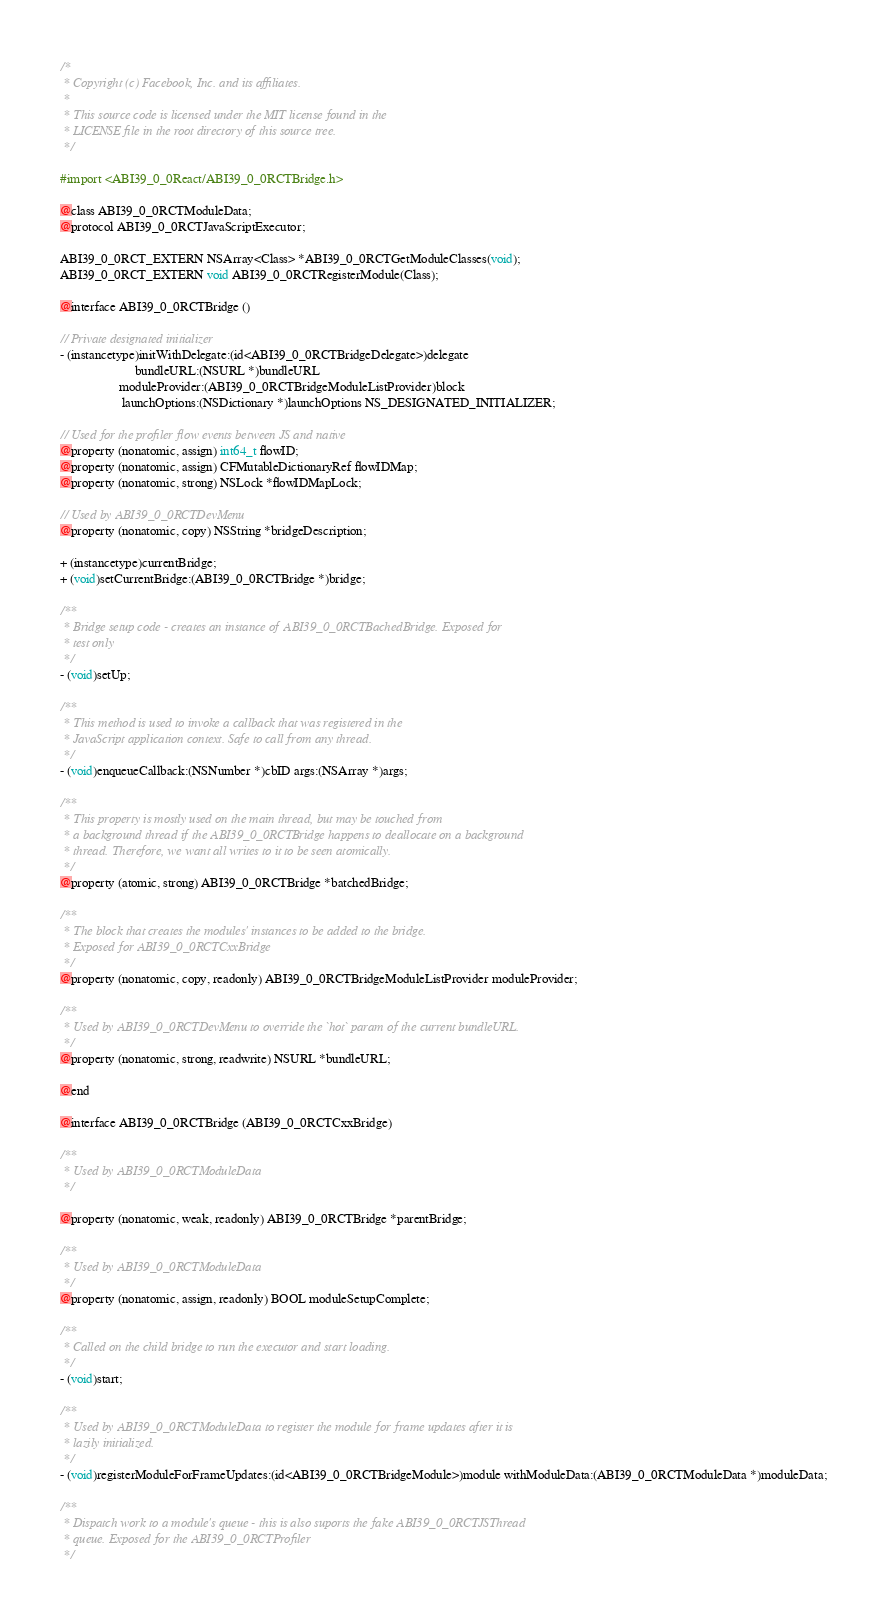Convert code to text. <code><loc_0><loc_0><loc_500><loc_500><_C_>/*
 * Copyright (c) Facebook, Inc. and its affiliates.
 *
 * This source code is licensed under the MIT license found in the
 * LICENSE file in the root directory of this source tree.
 */

#import <ABI39_0_0React/ABI39_0_0RCTBridge.h>

@class ABI39_0_0RCTModuleData;
@protocol ABI39_0_0RCTJavaScriptExecutor;

ABI39_0_0RCT_EXTERN NSArray<Class> *ABI39_0_0RCTGetModuleClasses(void);
ABI39_0_0RCT_EXTERN void ABI39_0_0RCTRegisterModule(Class);

@interface ABI39_0_0RCTBridge ()

// Private designated initializer
- (instancetype)initWithDelegate:(id<ABI39_0_0RCTBridgeDelegate>)delegate
                       bundleURL:(NSURL *)bundleURL
                  moduleProvider:(ABI39_0_0RCTBridgeModuleListProvider)block
                   launchOptions:(NSDictionary *)launchOptions NS_DESIGNATED_INITIALIZER;

// Used for the profiler flow events between JS and native
@property (nonatomic, assign) int64_t flowID;
@property (nonatomic, assign) CFMutableDictionaryRef flowIDMap;
@property (nonatomic, strong) NSLock *flowIDMapLock;

// Used by ABI39_0_0RCTDevMenu
@property (nonatomic, copy) NSString *bridgeDescription;

+ (instancetype)currentBridge;
+ (void)setCurrentBridge:(ABI39_0_0RCTBridge *)bridge;

/**
 * Bridge setup code - creates an instance of ABI39_0_0RCTBachedBridge. Exposed for
 * test only
 */
- (void)setUp;

/**
 * This method is used to invoke a callback that was registered in the
 * JavaScript application context. Safe to call from any thread.
 */
- (void)enqueueCallback:(NSNumber *)cbID args:(NSArray *)args;

/**
 * This property is mostly used on the main thread, but may be touched from
 * a background thread if the ABI39_0_0RCTBridge happens to deallocate on a background
 * thread. Therefore, we want all writes to it to be seen atomically.
 */
@property (atomic, strong) ABI39_0_0RCTBridge *batchedBridge;

/**
 * The block that creates the modules' instances to be added to the bridge.
 * Exposed for ABI39_0_0RCTCxxBridge
 */
@property (nonatomic, copy, readonly) ABI39_0_0RCTBridgeModuleListProvider moduleProvider;

/**
 * Used by ABI39_0_0RCTDevMenu to override the `hot` param of the current bundleURL.
 */
@property (nonatomic, strong, readwrite) NSURL *bundleURL;

@end

@interface ABI39_0_0RCTBridge (ABI39_0_0RCTCxxBridge)

/**
 * Used by ABI39_0_0RCTModuleData
 */

@property (nonatomic, weak, readonly) ABI39_0_0RCTBridge *parentBridge;

/**
 * Used by ABI39_0_0RCTModuleData
 */
@property (nonatomic, assign, readonly) BOOL moduleSetupComplete;

/**
 * Called on the child bridge to run the executor and start loading.
 */
- (void)start;

/**
 * Used by ABI39_0_0RCTModuleData to register the module for frame updates after it is
 * lazily initialized.
 */
- (void)registerModuleForFrameUpdates:(id<ABI39_0_0RCTBridgeModule>)module withModuleData:(ABI39_0_0RCTModuleData *)moduleData;

/**
 * Dispatch work to a module's queue - this is also suports the fake ABI39_0_0RCTJSThread
 * queue. Exposed for the ABI39_0_0RCTProfiler
 */</code> 